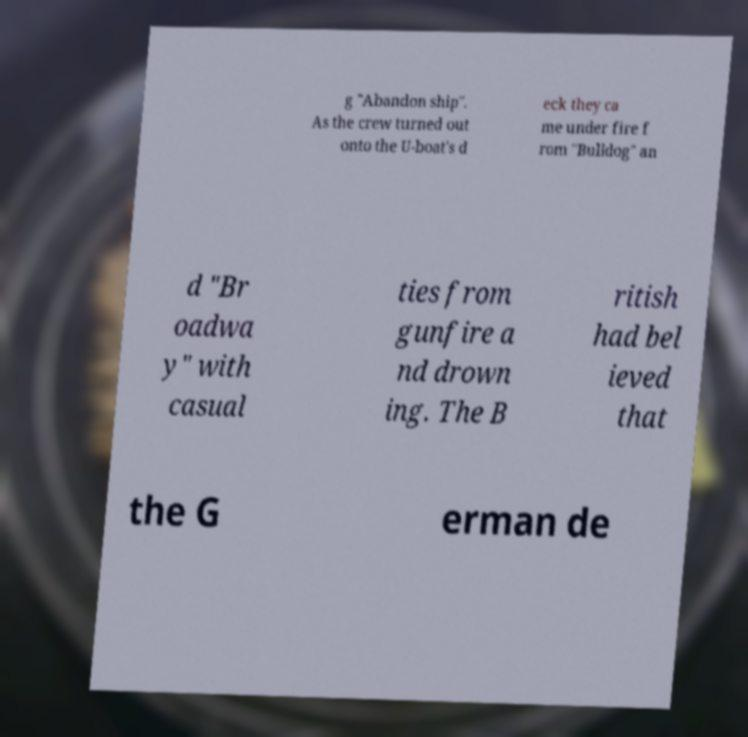For documentation purposes, I need the text within this image transcribed. Could you provide that? g "Abandon ship". As the crew turned out onto the U-boat's d eck they ca me under fire f rom "Bulldog" an d "Br oadwa y" with casual ties from gunfire a nd drown ing. The B ritish had bel ieved that the G erman de 